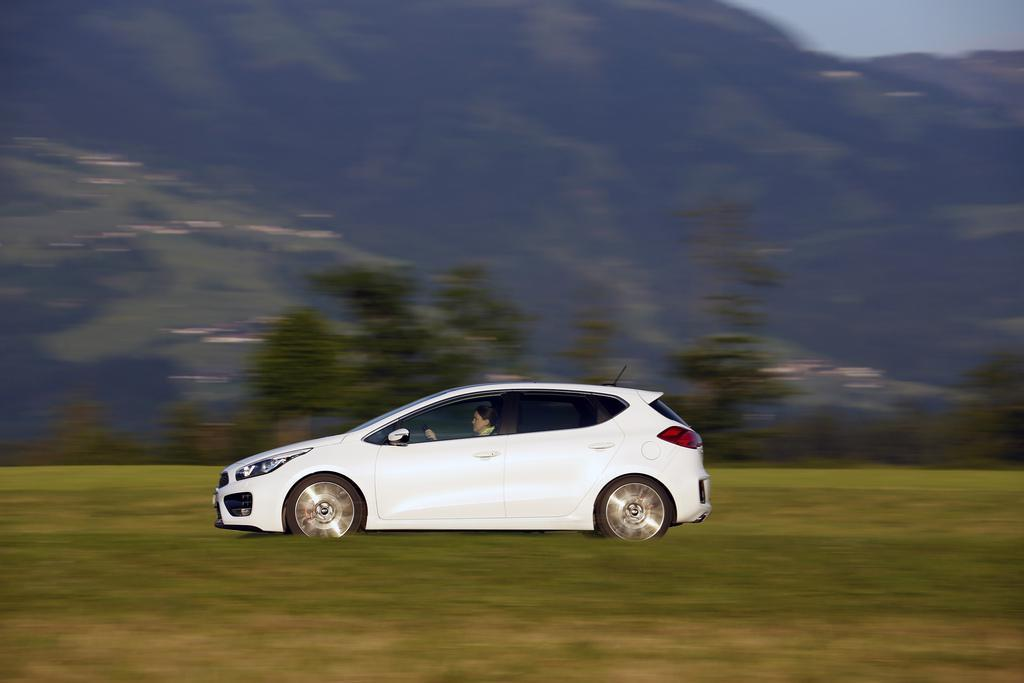What type of vehicle is in the image? There is a white car in the image. Where is the car located in relation to the mountains? The car is in front of mountains in the image. What other natural elements can be seen in the image? Trees are visible in the image. How many pizzas are being held by the balloon in the image? There are no pizzas or balloons present in the image. 